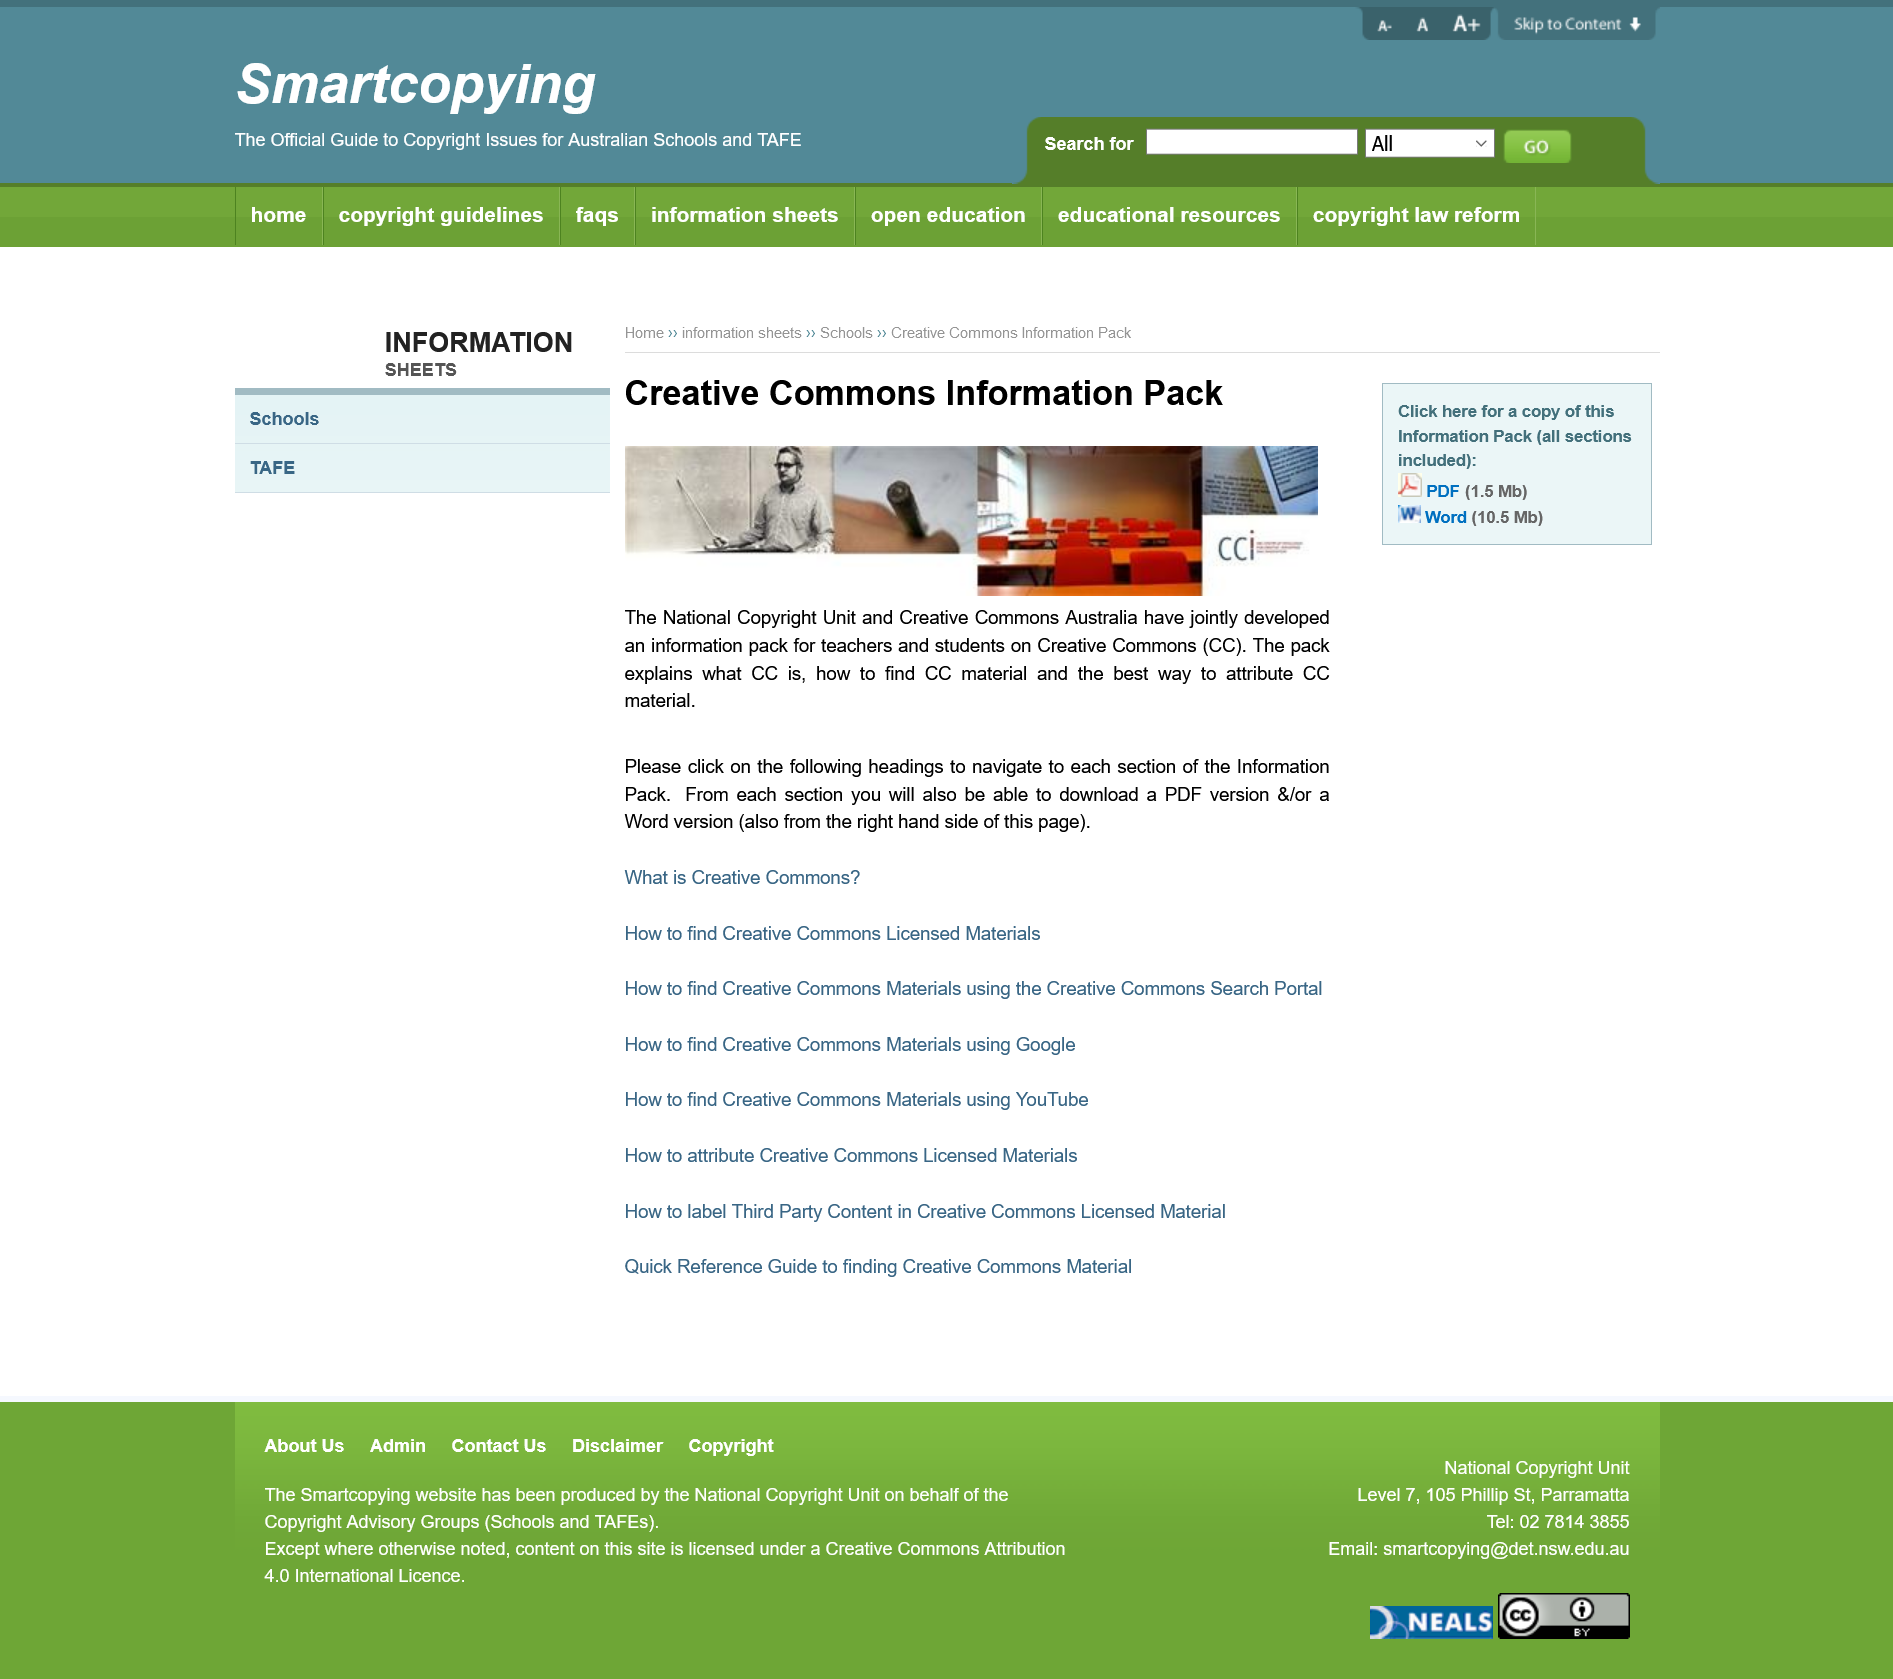Point out several critical features in this image. Yes, the Information Pack is available for download. The PDF or Word download is not solely developed for teachers, but for both teachers and students. CC" is an abbreviation that stands for "Creative Commons. 